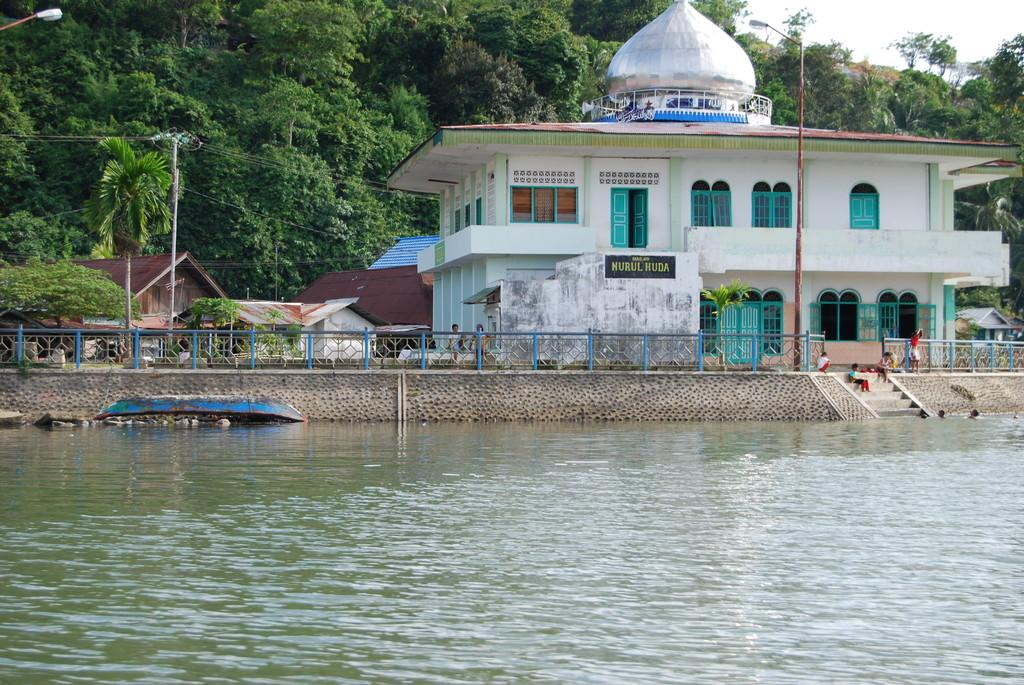What is the primary element visible in the image? There is water in the image. What type of structure can be seen in the image? There is a fence in the image. Are there any people present in the image? Yes, there are people in the image. What type of lighting is present in the image? There is a street lamp in the image. What type of utility pole is present in the image? There is a current pole in the image. What type of man-made structures can be seen in the image? There are buildings in the image. What type of vegetation is present in the image? There are trees in the image. What is visible at the top of the image? The sky is visible at the top of the image. What type of meal is being prepared in the image? There is no meal preparation visible in the image. What type of whip is being used by the people in the image? There is no whip present in the image. 